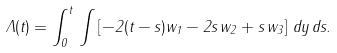Convert formula to latex. <formula><loc_0><loc_0><loc_500><loc_500>\Lambda ( t ) = \int _ { 0 } ^ { t } \, \int \left [ - 2 ( t - s ) w _ { 1 } - 2 s \, w _ { 2 } + s \, w _ { 3 } \right ] \, d y \, d s .</formula> 